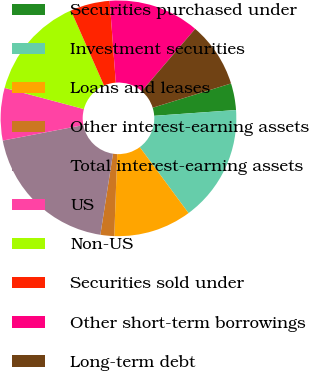Convert chart to OTSL. <chart><loc_0><loc_0><loc_500><loc_500><pie_chart><fcel>Securities purchased under<fcel>Investment securities<fcel>Loans and leases<fcel>Other interest-earning assets<fcel>Total interest-earning assets<fcel>US<fcel>Non-US<fcel>Securities sold under<fcel>Other short-term borrowings<fcel>Long-term debt<nl><fcel>3.66%<fcel>15.99%<fcel>10.7%<fcel>1.89%<fcel>19.52%<fcel>7.18%<fcel>14.23%<fcel>5.42%<fcel>12.47%<fcel>8.94%<nl></chart> 